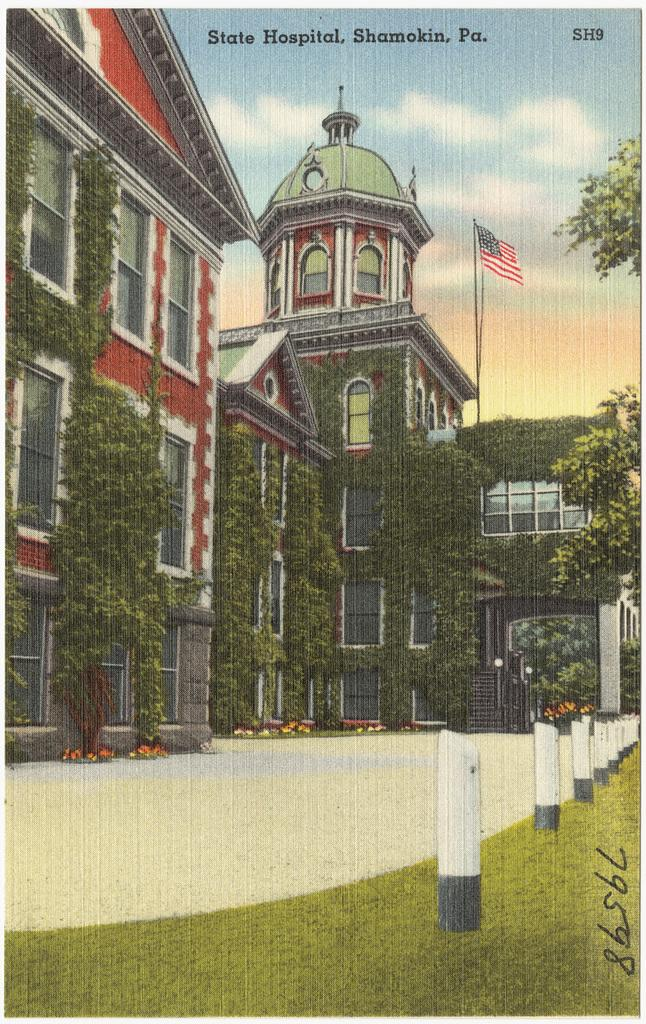What is featured on the poster in the image? The poster contains text and an image of buildings. What type of vegetation is growing on the building? Creeper plants are present on the building. What other natural elements can be seen in the image? There are trees in the image. What are the long, thin objects visible in the image? Rods are visible in the image. What is attached to the building? There is a flag on the building. What can be seen in the background of the image? The sky is visible in the background of the image. What type of vessel is being used by the students in the image? There are no students or vessels present in the image. Can you tell me how many fingers are visible on the person in the image? There is no person present in the image, so it is not possible to determine the number of fingers visible. 